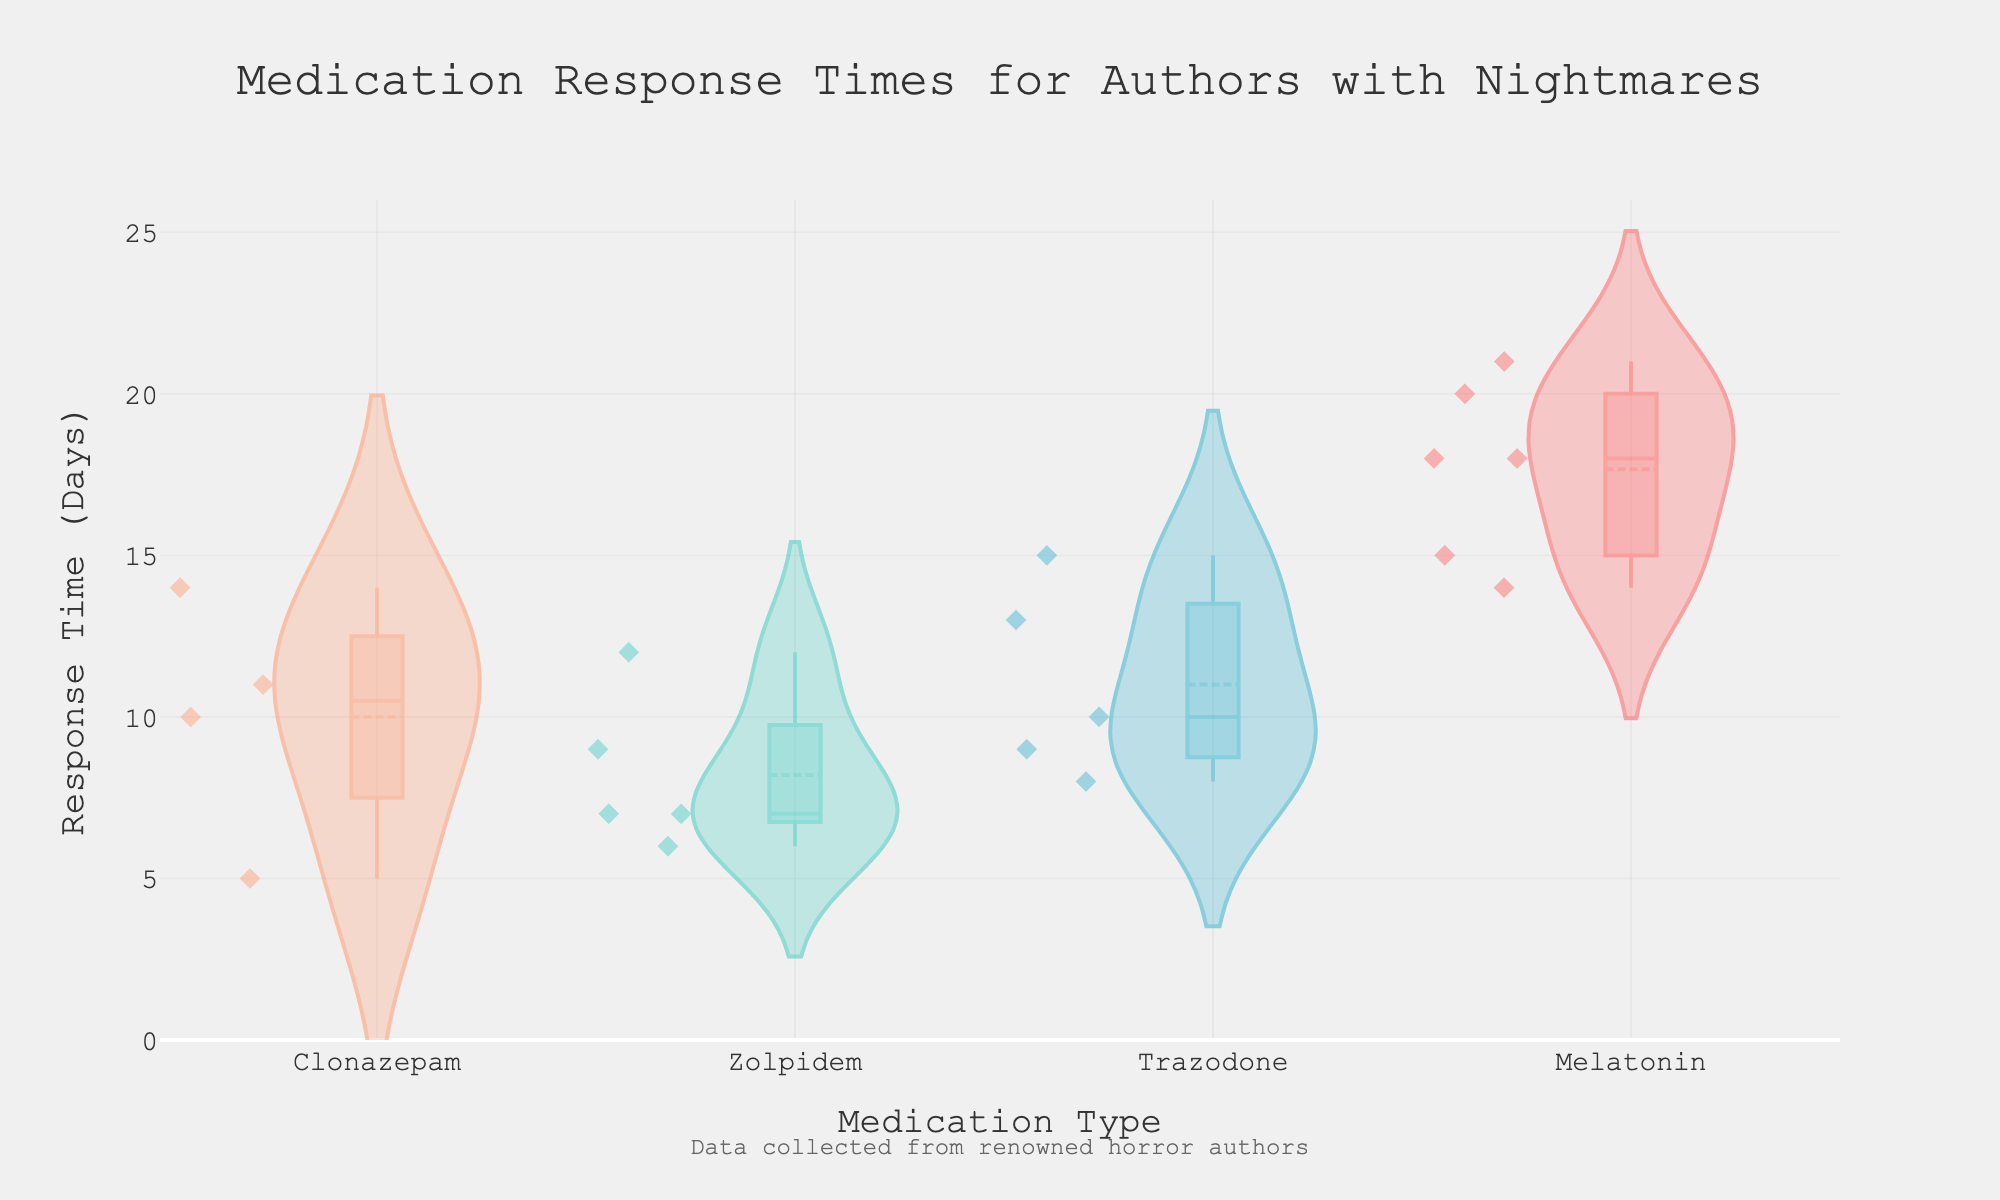What is the title of the figure? The title of the figure is displayed prominently at the top, which reads "Medication Response Times for Authors with Nightmares."
Answer: Medication Response Times for Authors with Nightmares Which medication has the highest average response time? To determine the highest average response time, observe the position of the meanline (a horizontal line within the violin plot) for each medication type. The medication with the highest meanline corresponds to the highest average response time.
Answer: Melatonin How many types of medications are shown in the figure? The figure shows multiple violin plots, each representing a different medication type. Count the unique categories on the x-axis to determine the total number of medication types.
Answer: 5 Which medication appears to have the lowest median response time? The median response time is represented by the middle line inside the box plot overlay within each violin plot. Identify the medication type with the lowest position of this median line.
Answer: Zolpidem What is the range of response times for Clonazepam? The range of response times can be found by looking at the span of the violin plot for Clonazepam, from the lowest to the highest values observed.
Answer: 5 to 14 days Which medication has the widest distribution of response times? The width of the distribution can be visualized by the spread of the violin plot. The medication with the most spread-out or widest violin plot shows the widest distribution of response times.
Answer: Trazodone Between Trazodone and Melatonin, which has a higher highest observed response time? Compare the topmost points of the violin plots (or the highest points where data points are visible) for Trazodone and Melatonin. Identify which medication's highest observed response time is higher.
Answer: Melatonin Which medication type has the most consistent response times (less variability)? Consistency in response times can be identified by looking at the violin plot with the narrowest spread, as it indicates less variability.
Answer: Zolpidem How many data points are there for Zolpidem? Count the number of individual data points marked within the Zolpidem violin plot. Each point represents a response time measurement.
Answer: 5 What can you infer about the effectiveness of Clonazepam compared to Zolpidem based on their response times? Observe the position of the median, mean line, and distribution of response times. Compare the lower medians and means of Clonazepam and Zolpidem to infer which might be more effective in reducing response times (assumed lower response times indicate better effectiveness).
Answer: Zolpidem appears more effective 